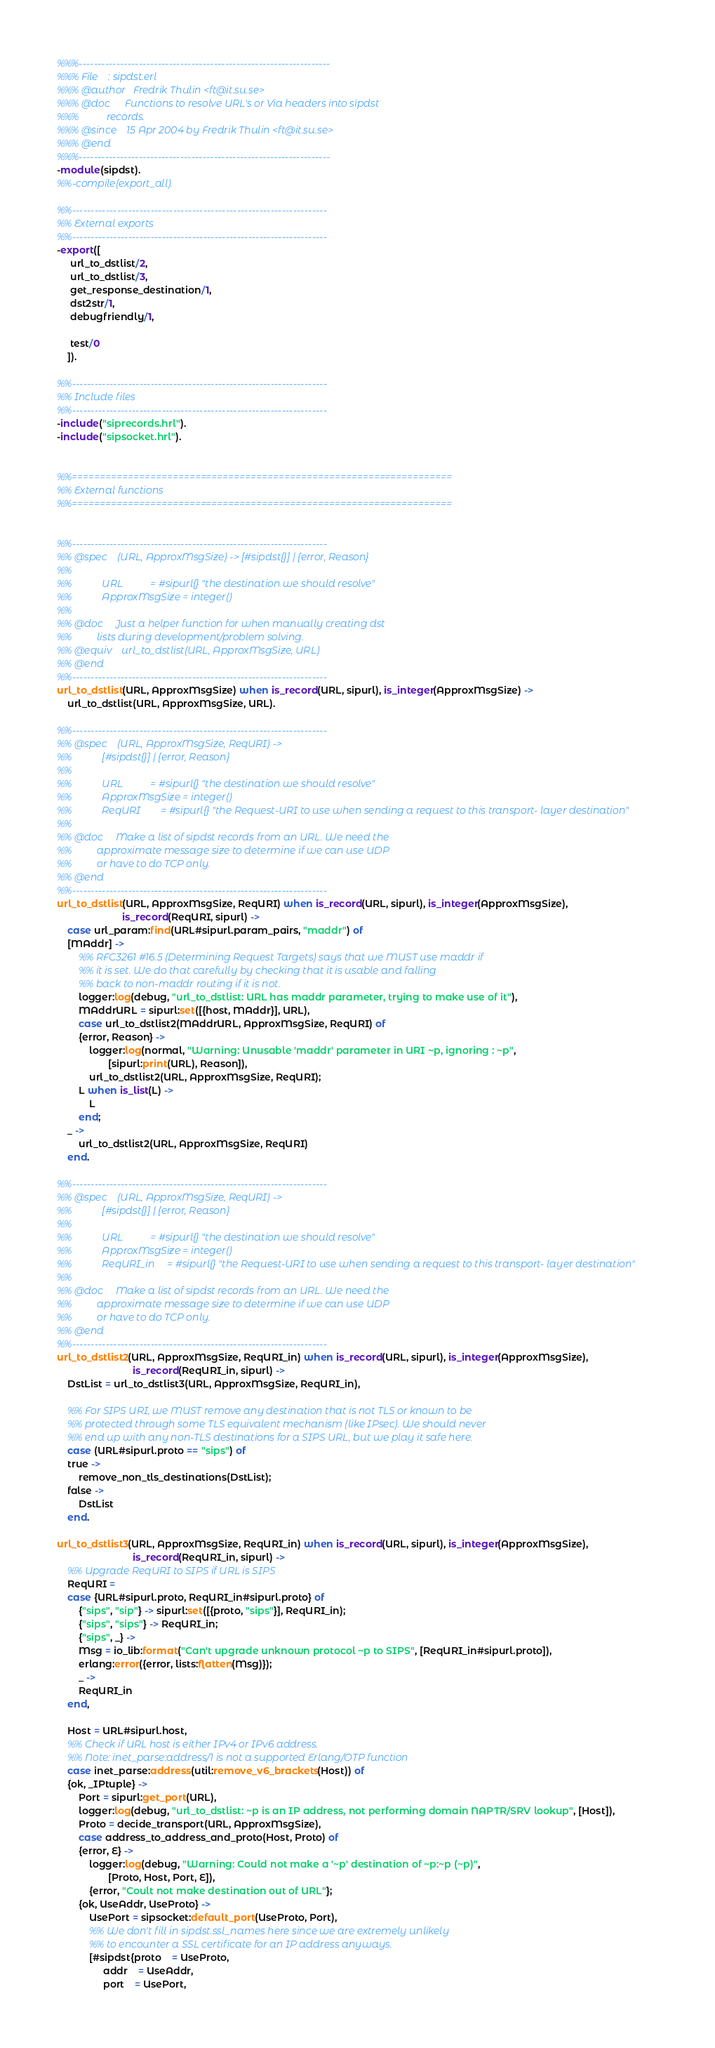<code> <loc_0><loc_0><loc_500><loc_500><_Erlang_>%%%-------------------------------------------------------------------
%%% File    : sipdst.erl
%%% @author   Fredrik Thulin <ft@it.su.se>
%%% @doc      Functions to resolve URL's or Via headers into sipdst
%%%           records.
%%% @since    15 Apr 2004 by Fredrik Thulin <ft@it.su.se>
%%% @end
%%%-------------------------------------------------------------------
-module(sipdst).
%%-compile(export_all).

%%--------------------------------------------------------------------
%% External exports
%%--------------------------------------------------------------------
-export([
	 url_to_dstlist/2,
	 url_to_dstlist/3,
	 get_response_destination/1,
	 dst2str/1,
	 debugfriendly/1,

	 test/0
	]).

%%--------------------------------------------------------------------
%% Include files
%%--------------------------------------------------------------------
-include("siprecords.hrl").
-include("sipsocket.hrl").


%%====================================================================
%% External functions
%%====================================================================


%%--------------------------------------------------------------------
%% @spec    (URL, ApproxMsgSize) -> [#sipdst{}] | {error, Reason}
%%
%%            URL           = #sipurl{} "the destination we should resolve"
%%            ApproxMsgSize = integer()
%%
%% @doc     Just a helper function for when manually creating dst
%%          lists during development/problem solving.
%% @equiv    url_to_dstlist(URL, ApproxMsgSize, URL)
%% @end
%%--------------------------------------------------------------------
url_to_dstlist(URL, ApproxMsgSize) when is_record(URL, sipurl), is_integer(ApproxMsgSize) ->
    url_to_dstlist(URL, ApproxMsgSize, URL).

%%--------------------------------------------------------------------
%% @spec    (URL, ApproxMsgSize, ReqURI) ->
%%            [#sipdst{}] | {error, Reason}
%%
%%            URL           = #sipurl{} "the destination we should resolve"
%%            ApproxMsgSize = integer()
%%            ReqURI        = #sipurl{} "the Request-URI to use when sending a request to this transport- layer destination"
%%
%% @doc     Make a list of sipdst records from an URL. We need the
%%          approximate message size to determine if we can use UDP
%%          or have to do TCP only.
%% @end
%%--------------------------------------------------------------------
url_to_dstlist(URL, ApproxMsgSize, ReqURI) when is_record(URL, sipurl), is_integer(ApproxMsgSize),
						is_record(ReqURI, sipurl) ->
    case url_param:find(URL#sipurl.param_pairs, "maddr") of
	[MAddr] ->
	    %% RFC3261 #16.5 (Determining Request Targets) says that we MUST use maddr if
	    %% it is set. We do that carefully by checking that it is usable and falling
	    %% back to non-maddr routing if it is not.
	    logger:log(debug, "url_to_dstlist: URL has maddr parameter, trying to make use of it"),
	    MAddrURL = sipurl:set([{host, MAddr}], URL),
	    case url_to_dstlist2(MAddrURL, ApproxMsgSize, ReqURI) of
		{error, Reason} ->
		    logger:log(normal, "Warning: Unusable 'maddr' parameter in URI ~p, ignoring : ~p",
			       [sipurl:print(URL), Reason]),
		    url_to_dstlist2(URL, ApproxMsgSize, ReqURI);
		L when is_list(L) ->
		    L
	    end;
	_ ->
	    url_to_dstlist2(URL, ApproxMsgSize, ReqURI)
    end.

%%--------------------------------------------------------------------
%% @spec    (URL, ApproxMsgSize, ReqURI) ->
%%            [#sipdst{}] | {error, Reason}
%%
%%            URL           = #sipurl{} "the destination we should resolve"
%%            ApproxMsgSize = integer()
%%            ReqURI_in     = #sipurl{} "the Request-URI to use when sending a request to this transport- layer destination"
%%
%% @doc     Make a list of sipdst records from an URL. We need the
%%          approximate message size to determine if we can use UDP
%%          or have to do TCP only.
%% @end
%%--------------------------------------------------------------------
url_to_dstlist2(URL, ApproxMsgSize, ReqURI_in) when is_record(URL, sipurl), is_integer(ApproxMsgSize),
						    is_record(ReqURI_in, sipurl) ->
    DstList = url_to_dstlist3(URL, ApproxMsgSize, ReqURI_in),

    %% For SIPS URI, we MUST remove any destination that is not TLS or known to be
    %% protected through some TLS equivalent mechanism (like IPsec). We should never
    %% end up with any non-TLS destinations for a SIPS URL, but we play it safe here.
    case (URL#sipurl.proto == "sips") of
	true ->
	    remove_non_tls_destinations(DstList);
	false ->
	    DstList
    end.

url_to_dstlist3(URL, ApproxMsgSize, ReqURI_in) when is_record(URL, sipurl), is_integer(ApproxMsgSize),
						    is_record(ReqURI_in, sipurl) ->
    %% Upgrade ReqURI to SIPS if URL is SIPS
    ReqURI =
	case {URL#sipurl.proto, ReqURI_in#sipurl.proto} of
	    {"sips", "sip"} -> sipurl:set([{proto, "sips"}], ReqURI_in);
	    {"sips", "sips"} -> ReqURI_in;
	    {"sips", _} ->
		Msg = io_lib:format("Can't upgrade unknown protocol ~p to SIPS", [ReqURI_in#sipurl.proto]),
		erlang:error({error, lists:flatten(Msg)});
	    _ ->
		ReqURI_in
	end,

    Host = URL#sipurl.host,
    %% Check if URL host is either IPv4 or IPv6 address.
    %% Note: inet_parse:address/1 is not a supported Erlang/OTP function
    case inet_parse:address(util:remove_v6_brackets(Host)) of
	{ok, _IPtuple} ->
	    Port = sipurl:get_port(URL),
	    logger:log(debug, "url_to_dstlist: ~p is an IP address, not performing domain NAPTR/SRV lookup", [Host]),
	    Proto = decide_transport(URL, ApproxMsgSize),
	    case address_to_address_and_proto(Host, Proto) of
		{error, E} ->
		    logger:log(debug, "Warning: Could not make a '~p' destination of ~p:~p (~p)",
			       [Proto, Host, Port, E]),
		    {error, "Coult not make destination out of URL"};
		{ok, UseAddr, UseProto} ->
		    UsePort = sipsocket:default_port(UseProto, Port),
		    %% We don't fill in sipdst.ssl_names here since we are extremely unlikely
		    %% to encounter a SSL certificate for an IP address anyways.
		    [#sipdst{proto	= UseProto,
			     addr	= UseAddr,
			     port	= UsePort,</code> 